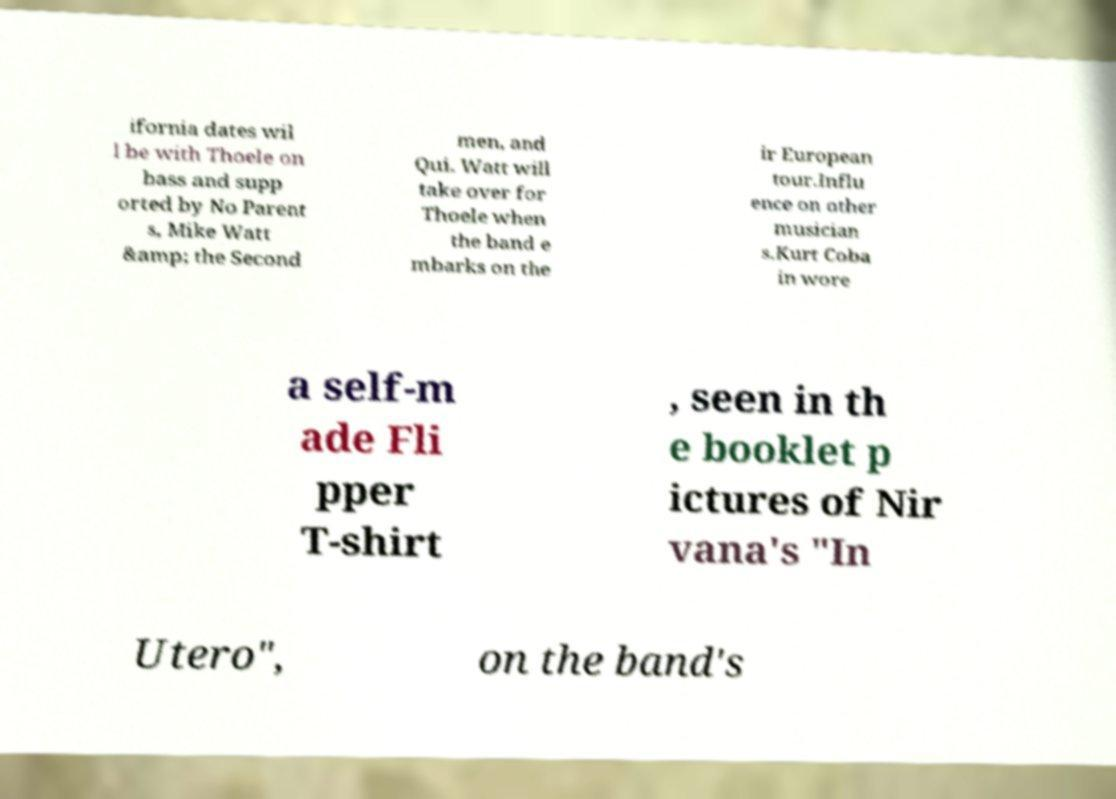Can you accurately transcribe the text from the provided image for me? ifornia dates wil l be with Thoele on bass and supp orted by No Parent s, Mike Watt &amp; the Second men, and Qui. Watt will take over for Thoele when the band e mbarks on the ir European tour.Influ ence on other musician s.Kurt Coba in wore a self-m ade Fli pper T-shirt , seen in th e booklet p ictures of Nir vana's "In Utero", on the band's 